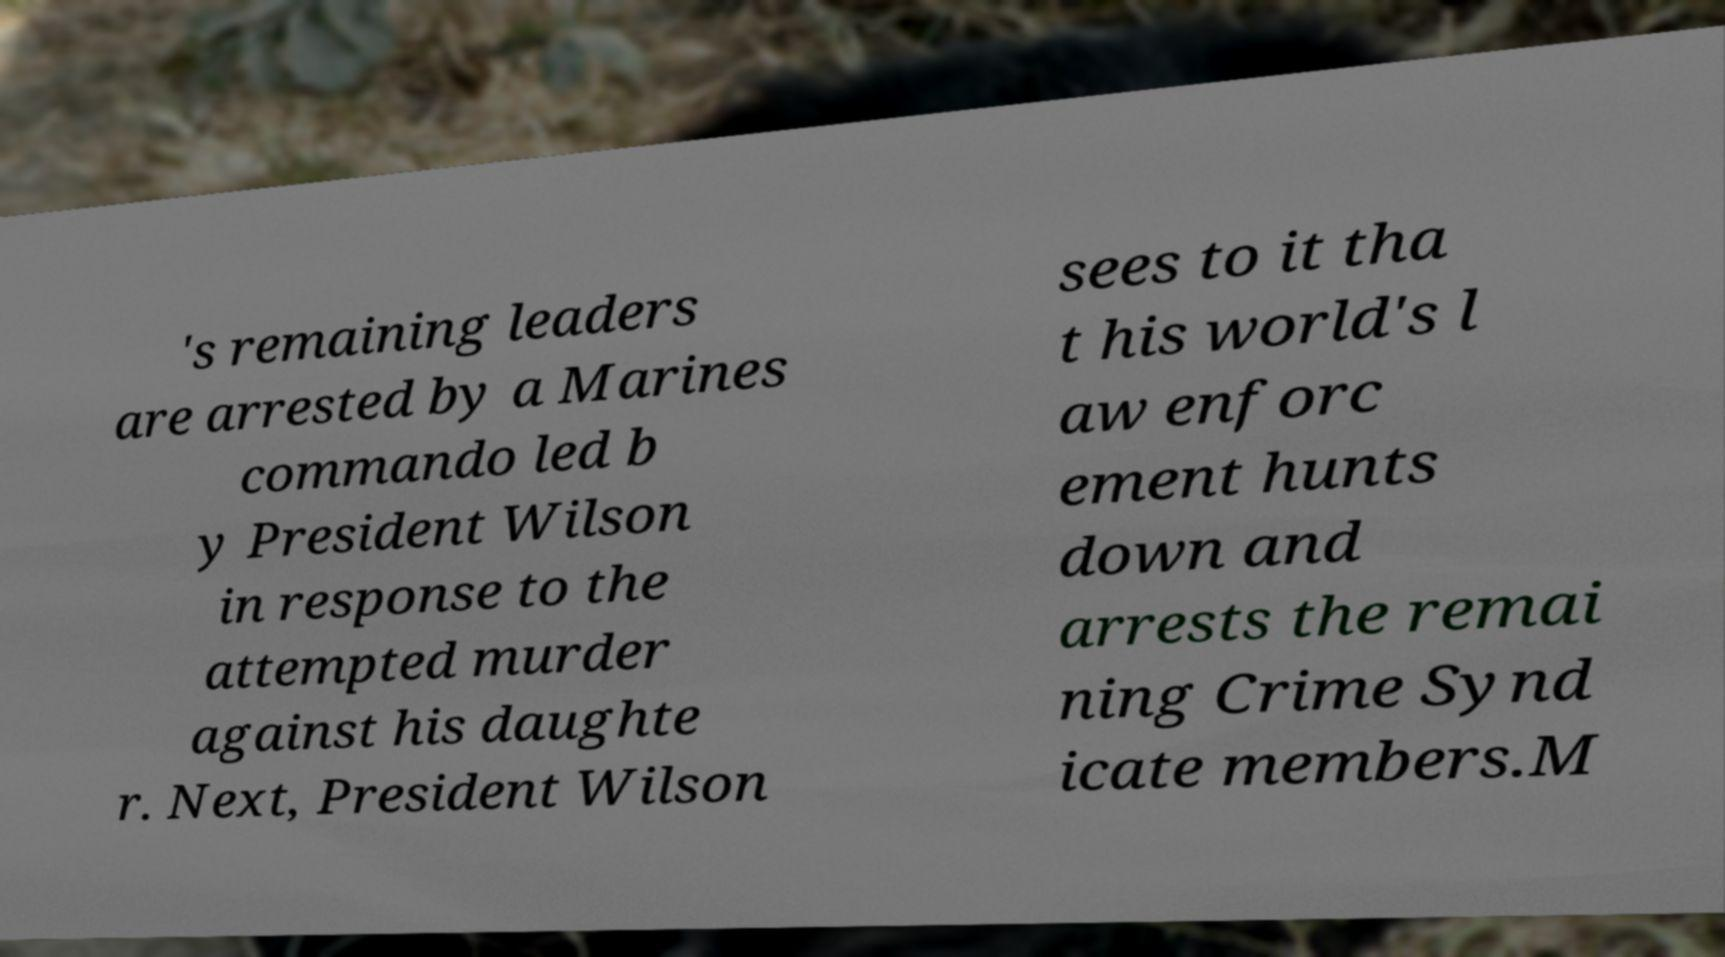Please read and relay the text visible in this image. What does it say? 's remaining leaders are arrested by a Marines commando led b y President Wilson in response to the attempted murder against his daughte r. Next, President Wilson sees to it tha t his world's l aw enforc ement hunts down and arrests the remai ning Crime Synd icate members.M 